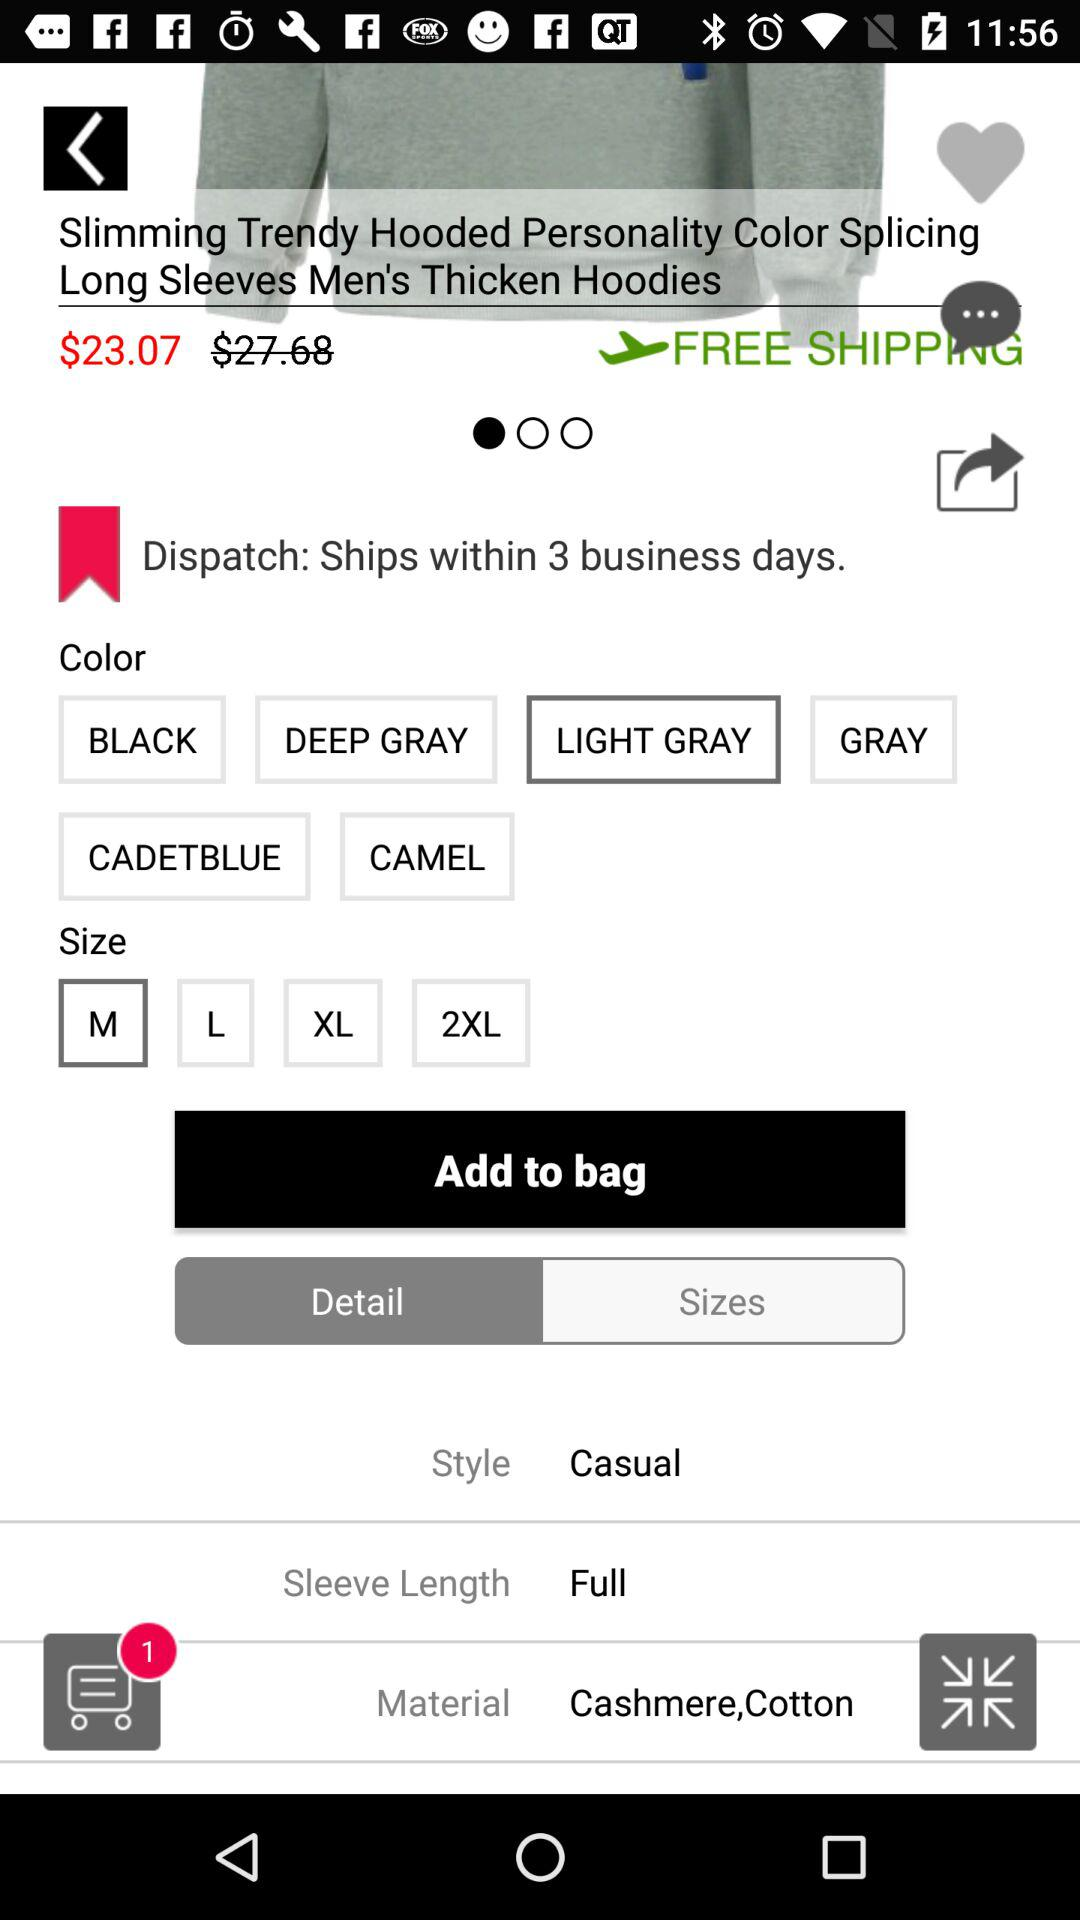Which colour is selected? The selected colour is "LIGHT GRAY". 